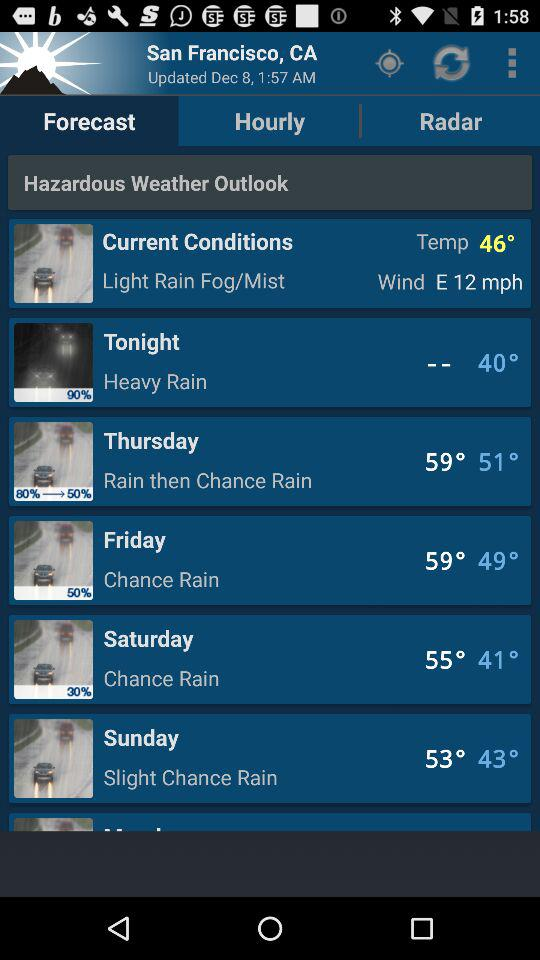Which tab is selected? The selected tab is "Forecast". 